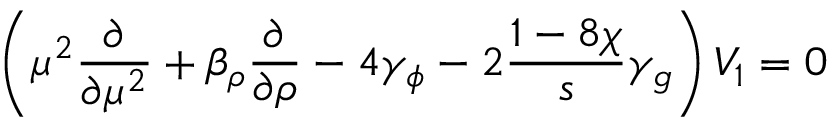Convert formula to latex. <formula><loc_0><loc_0><loc_500><loc_500>\left ( \mu ^ { 2 } \frac { \partial } { \partial \mu ^ { 2 } } + \beta _ { \rho } \frac { \partial } { \partial \rho } - 4 \gamma _ { \phi } - 2 \frac { 1 - 8 \chi } { s } \gamma _ { g } \right ) V _ { 1 } = 0</formula> 